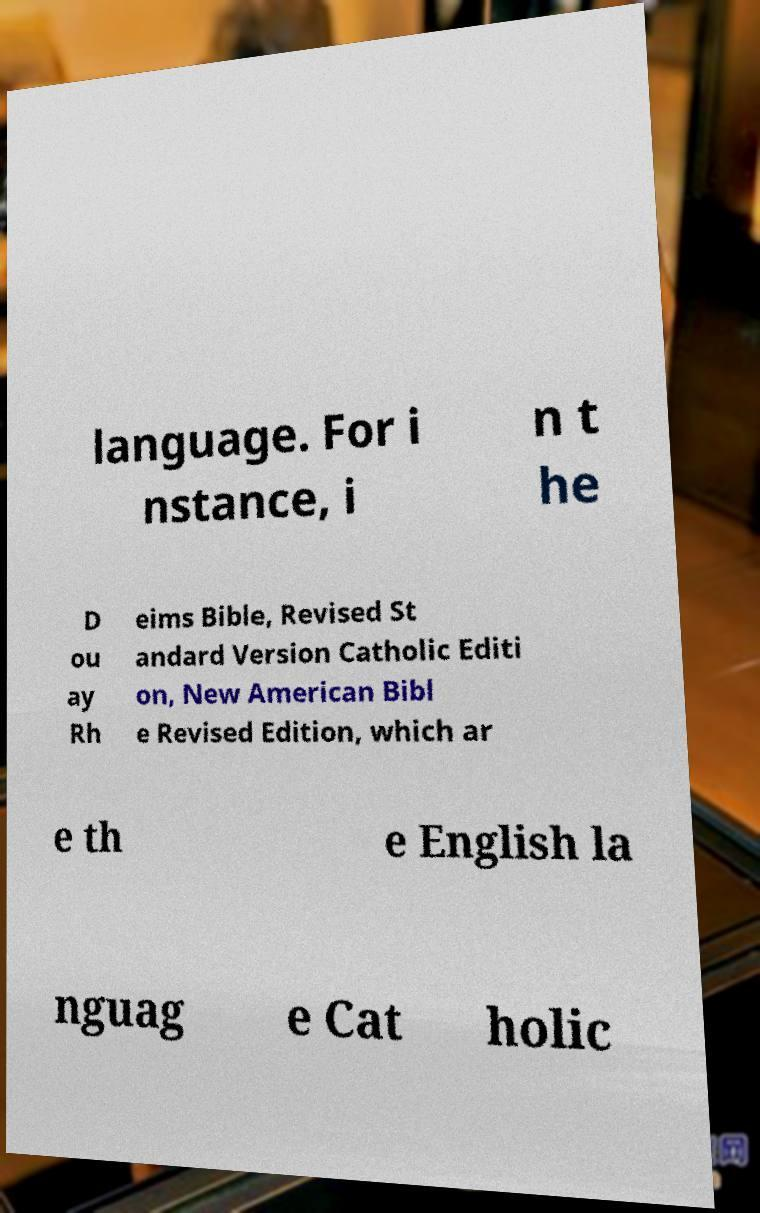Could you extract and type out the text from this image? language. For i nstance, i n t he D ou ay Rh eims Bible, Revised St andard Version Catholic Editi on, New American Bibl e Revised Edition, which ar e th e English la nguag e Cat holic 